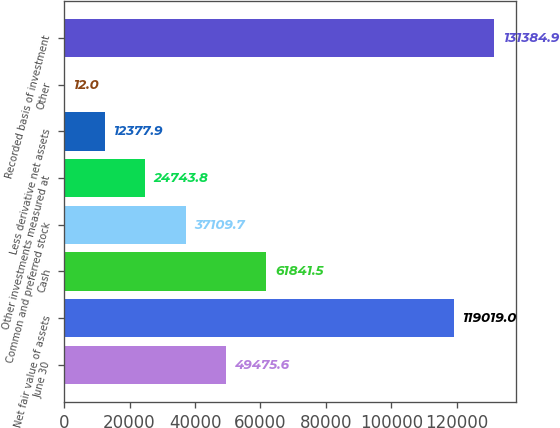<chart> <loc_0><loc_0><loc_500><loc_500><bar_chart><fcel>June 30<fcel>Net fair value of assets<fcel>Cash<fcel>Common and preferred stock<fcel>Other investments measured at<fcel>Less derivative net assets<fcel>Other<fcel>Recorded basis of investment<nl><fcel>49475.6<fcel>119019<fcel>61841.5<fcel>37109.7<fcel>24743.8<fcel>12377.9<fcel>12<fcel>131385<nl></chart> 